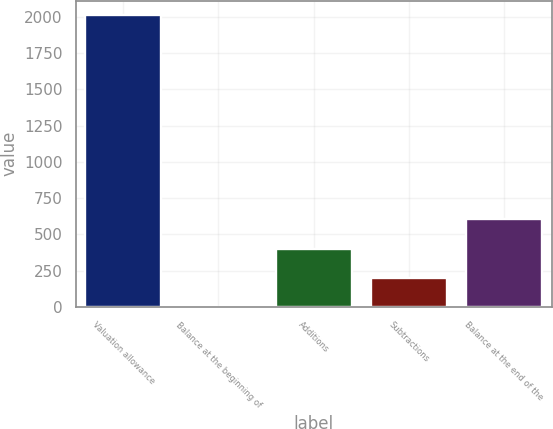Convert chart. <chart><loc_0><loc_0><loc_500><loc_500><bar_chart><fcel>Valuation allowance<fcel>Balance at the beginning of<fcel>Additions<fcel>Subtractions<fcel>Balance at the end of the<nl><fcel>2010<fcel>0.24<fcel>402.2<fcel>201.22<fcel>603.18<nl></chart> 